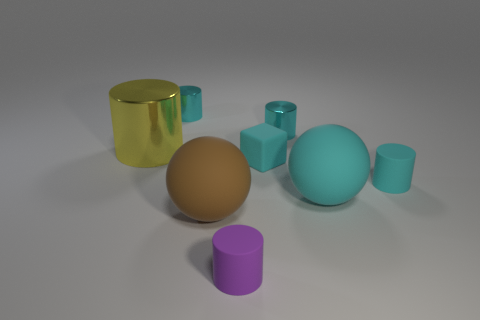There is a tiny shiny object that is right of the small purple cylinder; what is its shape?
Provide a succinct answer. Cylinder. Is the number of small purple cylinders less than the number of large gray objects?
Give a very brief answer. No. Are there any other things that have the same color as the big metal thing?
Give a very brief answer. No. What is the size of the brown sphere that is left of the cyan matte sphere?
Make the answer very short. Large. Is the number of brown rubber spheres greater than the number of large gray matte spheres?
Ensure brevity in your answer.  Yes. What is the large cyan thing made of?
Keep it short and to the point. Rubber. What number of other things are there of the same material as the small purple object
Your response must be concise. 4. How many large blue cylinders are there?
Make the answer very short. 0. There is another purple thing that is the same shape as the big metal thing; what material is it?
Your response must be concise. Rubber. Is the tiny cylinder right of the large cyan rubber ball made of the same material as the purple object?
Provide a short and direct response. Yes. 